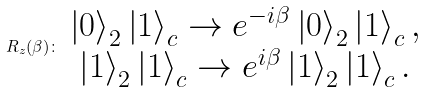Convert formula to latex. <formula><loc_0><loc_0><loc_500><loc_500>R _ { z } ( \beta ) \colon \begin{array} { c } \left | 0 \right \rangle _ { 2 } \left | 1 \right \rangle _ { c } \rightarrow e ^ { - i \beta } \left | 0 \right \rangle _ { 2 } \left | 1 \right \rangle _ { c } , \\ \left | 1 \right \rangle _ { 2 } \left | 1 \right \rangle _ { c } \rightarrow e ^ { i \beta } \left | 1 \right \rangle _ { 2 } \left | 1 \right \rangle _ { c } . \end{array}</formula> 